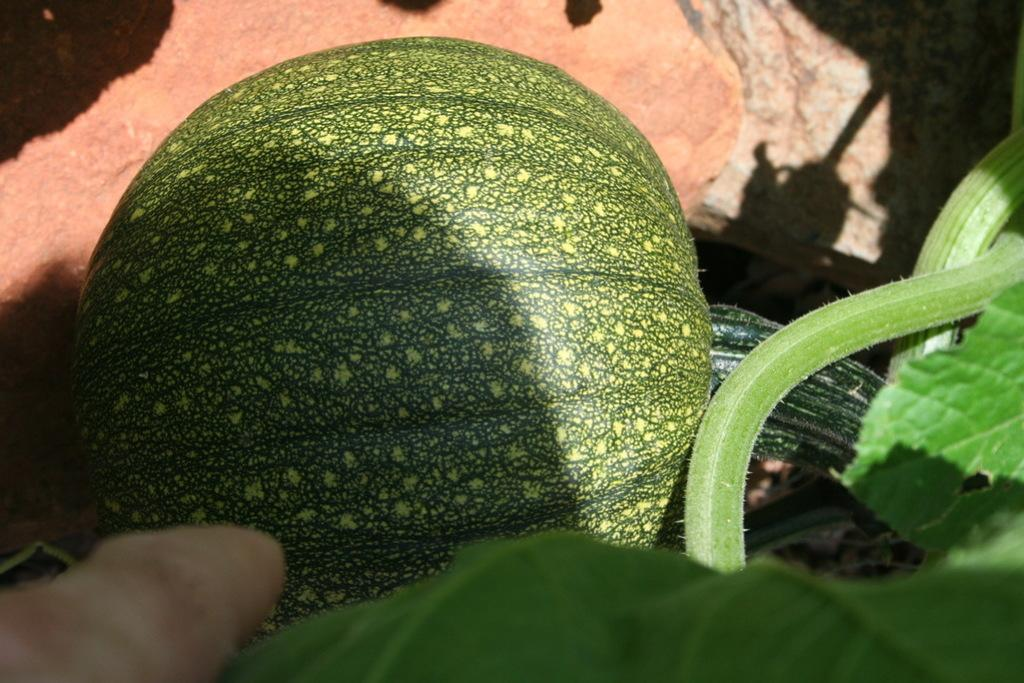What type of living organism can be seen in the image? There is a fruit on a plant in the image. What can be seen in the background of the image? The ground is visible in the background of the image. Where is the sink located in the image? There is no sink present in the image. Can you see a person in the image? There is no person present in the image. What type of material is the thread made of in the image? There is no thread present in the image. 